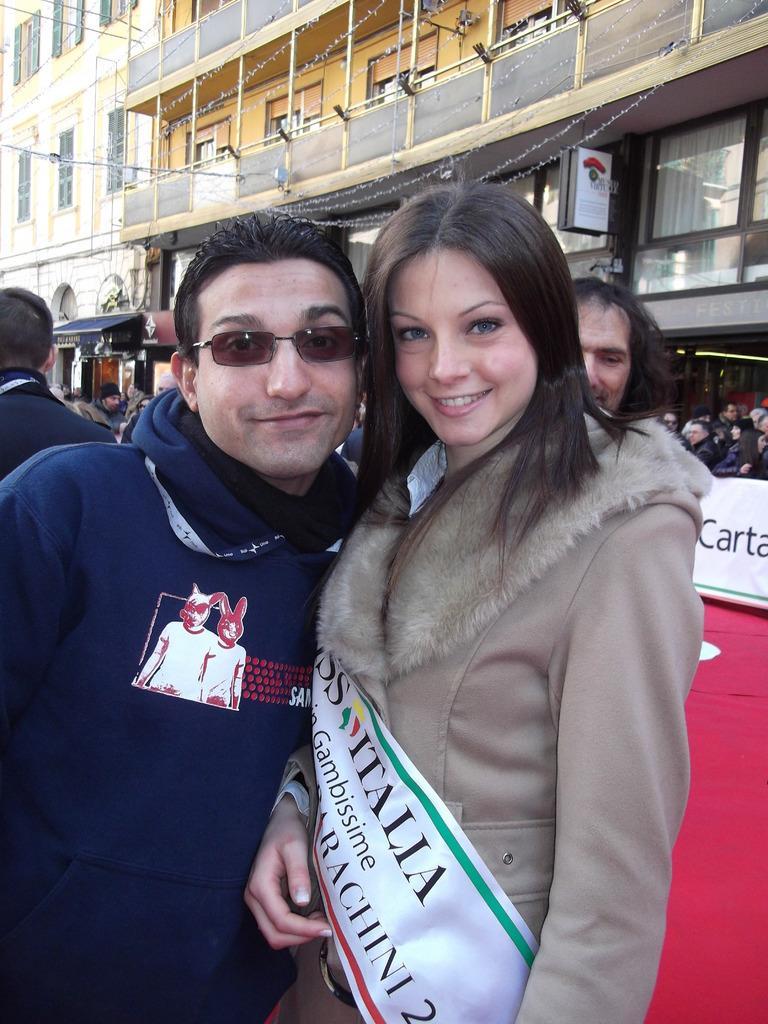How would you summarize this image in a sentence or two? In this image I can see two persons. The person at right wearing cream jacket and the person at left wearing blue jacket, at the back I can see few other persons standing, building in yellow color and a white color board attached to a pole 